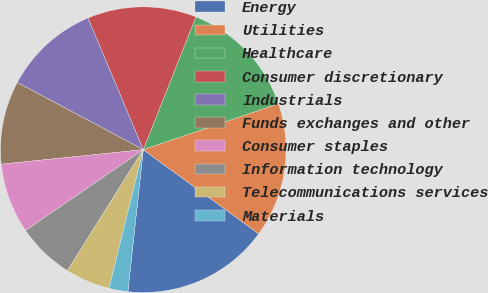Convert chart. <chart><loc_0><loc_0><loc_500><loc_500><pie_chart><fcel>Energy<fcel>Utilities<fcel>Healthcare<fcel>Consumer discretionary<fcel>Industrials<fcel>Funds exchanges and other<fcel>Consumer staples<fcel>Information technology<fcel>Telecommunications services<fcel>Materials<nl><fcel>16.7%<fcel>15.24%<fcel>13.78%<fcel>12.33%<fcel>10.87%<fcel>9.42%<fcel>7.96%<fcel>6.51%<fcel>5.05%<fcel>2.14%<nl></chart> 